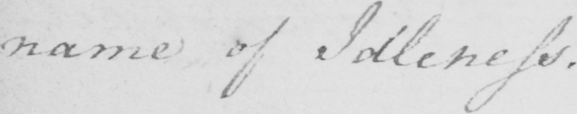What text is written in this handwritten line? name of Idleness . 